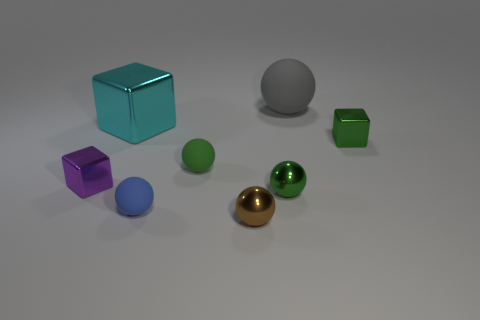Subtract all tiny purple shiny cubes. How many cubes are left? 2 Subtract all purple blocks. How many blocks are left? 2 Subtract 1 blocks. How many blocks are left? 2 Add 2 brown metal cubes. How many objects exist? 10 Subtract all spheres. How many objects are left? 3 Add 2 blue shiny cylinders. How many blue shiny cylinders exist? 2 Subtract 1 blue spheres. How many objects are left? 7 Subtract all cyan balls. Subtract all red cubes. How many balls are left? 5 Subtract all red balls. How many green blocks are left? 1 Subtract all tiny purple blocks. Subtract all large gray balls. How many objects are left? 6 